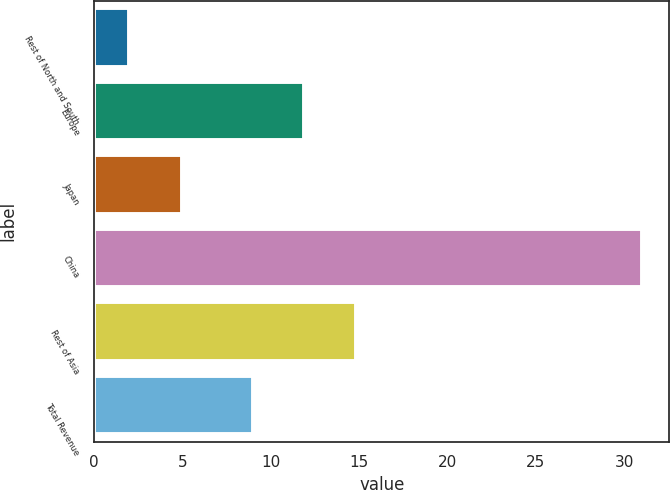<chart> <loc_0><loc_0><loc_500><loc_500><bar_chart><fcel>Rest of North and South<fcel>Europe<fcel>Japan<fcel>China<fcel>Rest of Asia<fcel>Total Revenue<nl><fcel>2<fcel>11.9<fcel>5<fcel>31<fcel>14.8<fcel>9<nl></chart> 